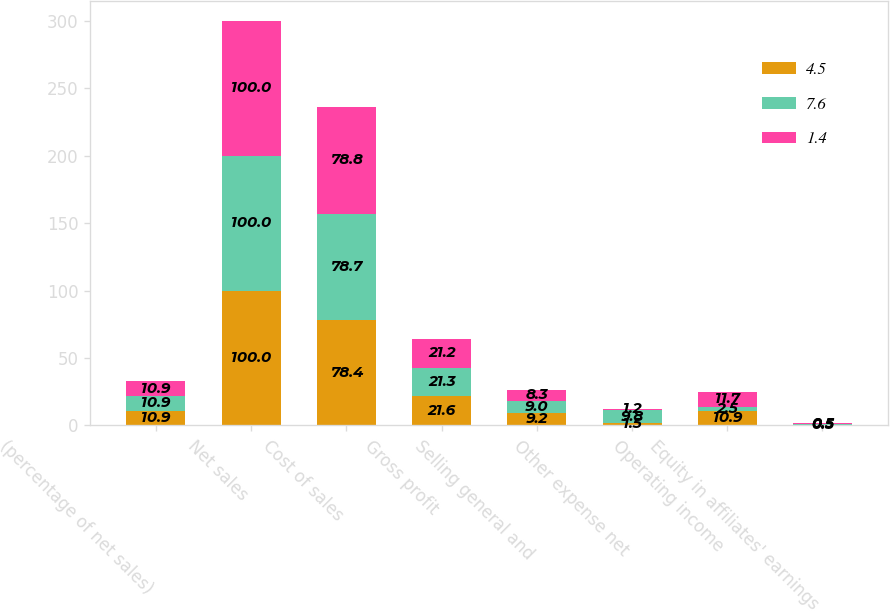Convert chart to OTSL. <chart><loc_0><loc_0><loc_500><loc_500><stacked_bar_chart><ecel><fcel>(percentage of net sales)<fcel>Net sales<fcel>Cost of sales<fcel>Gross profit<fcel>Selling general and<fcel>Other expense net<fcel>Operating income<fcel>Equity in affiliates' earnings<nl><fcel>4.5<fcel>10.9<fcel>100<fcel>78.4<fcel>21.6<fcel>9.2<fcel>1.5<fcel>10.9<fcel>0.5<nl><fcel>7.6<fcel>10.9<fcel>100<fcel>78.7<fcel>21.3<fcel>9<fcel>9.8<fcel>2.5<fcel>0.5<nl><fcel>1.4<fcel>10.9<fcel>100<fcel>78.8<fcel>21.2<fcel>8.3<fcel>1.2<fcel>11.7<fcel>0.5<nl></chart> 